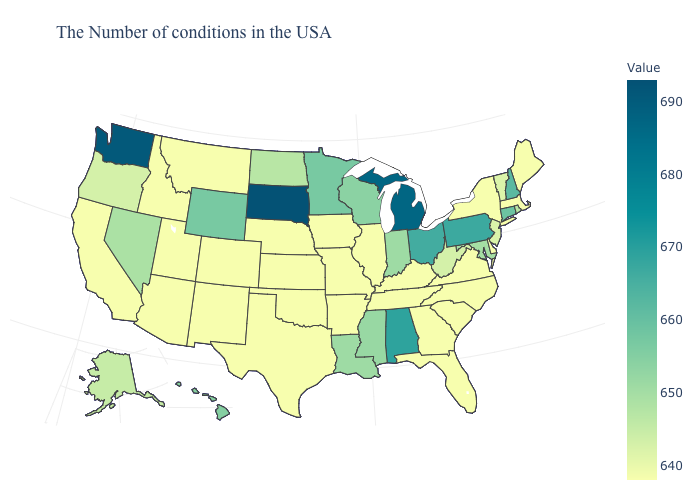Does South Dakota have the highest value in the USA?
Quick response, please. Yes. Does the map have missing data?
Answer briefly. No. Is the legend a continuous bar?
Give a very brief answer. Yes. Which states have the highest value in the USA?
Give a very brief answer. South Dakota. Does Mississippi have a higher value than Alabama?
Keep it brief. No. Does Mississippi have the lowest value in the South?
Concise answer only. No. 